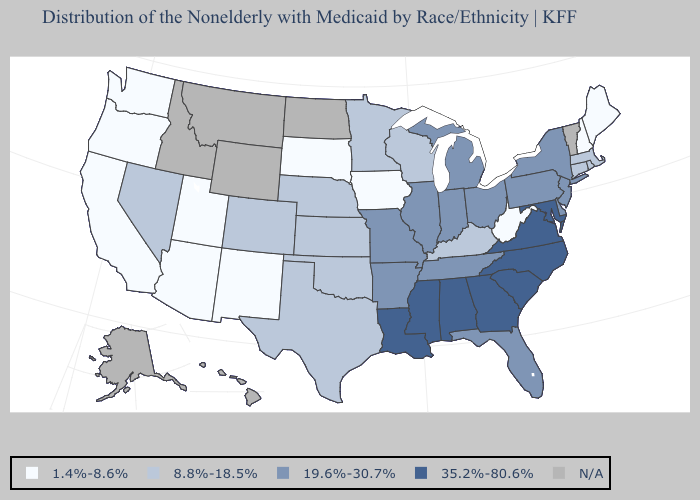What is the value of Oregon?
Short answer required. 1.4%-8.6%. Name the states that have a value in the range N/A?
Answer briefly. Alaska, Hawaii, Idaho, Montana, North Dakota, Vermont, Wyoming. Does Louisiana have the highest value in the USA?
Give a very brief answer. Yes. Does the map have missing data?
Short answer required. Yes. Name the states that have a value in the range 1.4%-8.6%?
Answer briefly. Arizona, California, Iowa, Maine, New Hampshire, New Mexico, Oregon, South Dakota, Utah, Washington, West Virginia. Among the states that border Minnesota , does Wisconsin have the lowest value?
Give a very brief answer. No. Name the states that have a value in the range 19.6%-30.7%?
Keep it brief. Arkansas, Delaware, Florida, Illinois, Indiana, Michigan, Missouri, New Jersey, New York, Ohio, Pennsylvania, Tennessee. Among the states that border Illinois , does Iowa have the lowest value?
Answer briefly. Yes. Which states have the highest value in the USA?
Keep it brief. Alabama, Georgia, Louisiana, Maryland, Mississippi, North Carolina, South Carolina, Virginia. Which states have the lowest value in the USA?
Give a very brief answer. Arizona, California, Iowa, Maine, New Hampshire, New Mexico, Oregon, South Dakota, Utah, Washington, West Virginia. What is the value of Arkansas?
Concise answer only. 19.6%-30.7%. What is the value of Arizona?
Give a very brief answer. 1.4%-8.6%. What is the lowest value in states that border Washington?
Concise answer only. 1.4%-8.6%. What is the value of Maryland?
Concise answer only. 35.2%-80.6%. 